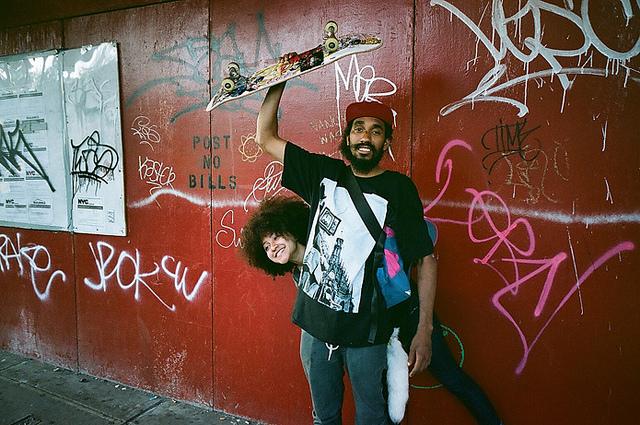Are both people standing up straight?
Be succinct. No. Are these two a couple?
Keep it brief. Yes. Are they happy or sad?
Short answer required. Happy. 